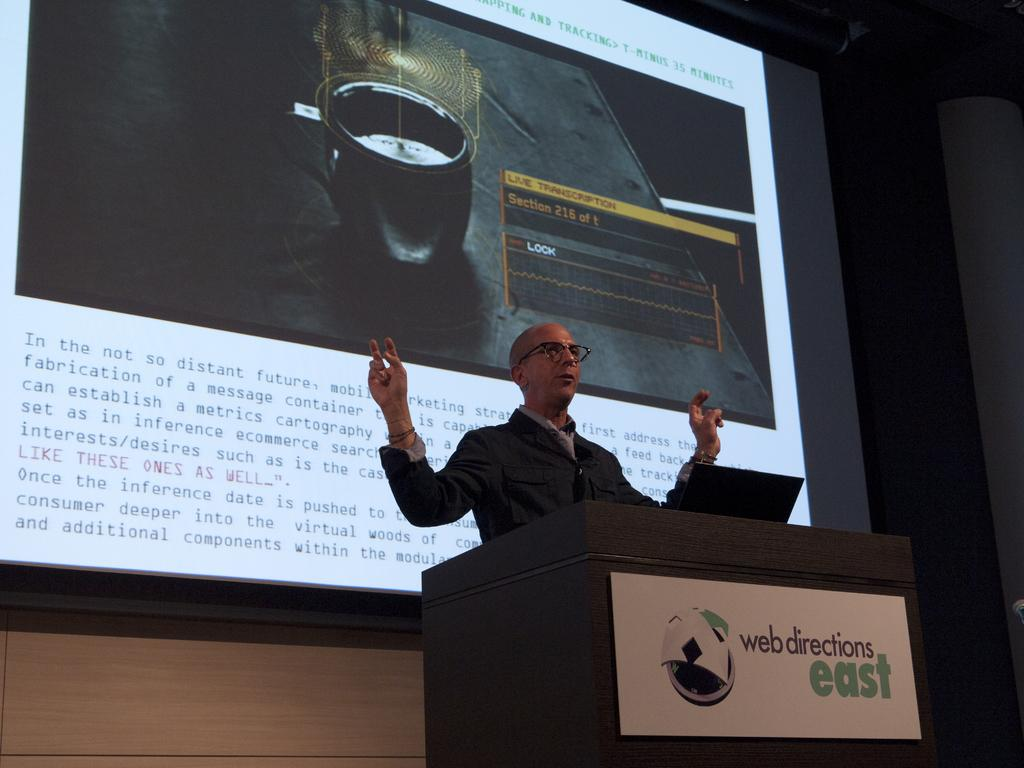What is the main subject of the picture? The main subject of the picture is a man standing in the middle of the picture. What is the man standing in front of? The man is in front of a podium. What can be seen behind the man? There is a large screen behind the man. What information is displayed on the large screen? There is text visible on the large screen. Is there a beggar asking for support in the image? There is no beggar or mention of support in the image; it features a man standing in front of a podium with a large screen behind him. Can you see a coach giving instructions to the man in the image? There is no coach or any indication of instructions being given in the image. 